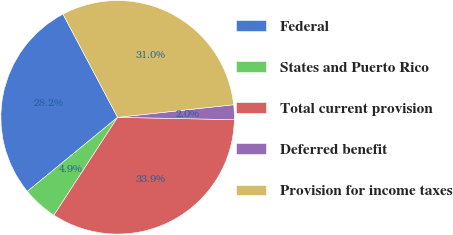Convert chart to OTSL. <chart><loc_0><loc_0><loc_500><loc_500><pie_chart><fcel>Federal<fcel>States and Puerto Rico<fcel>Total current provision<fcel>Deferred benefit<fcel>Provision for income taxes<nl><fcel>28.19%<fcel>4.88%<fcel>33.87%<fcel>2.04%<fcel>31.03%<nl></chart> 